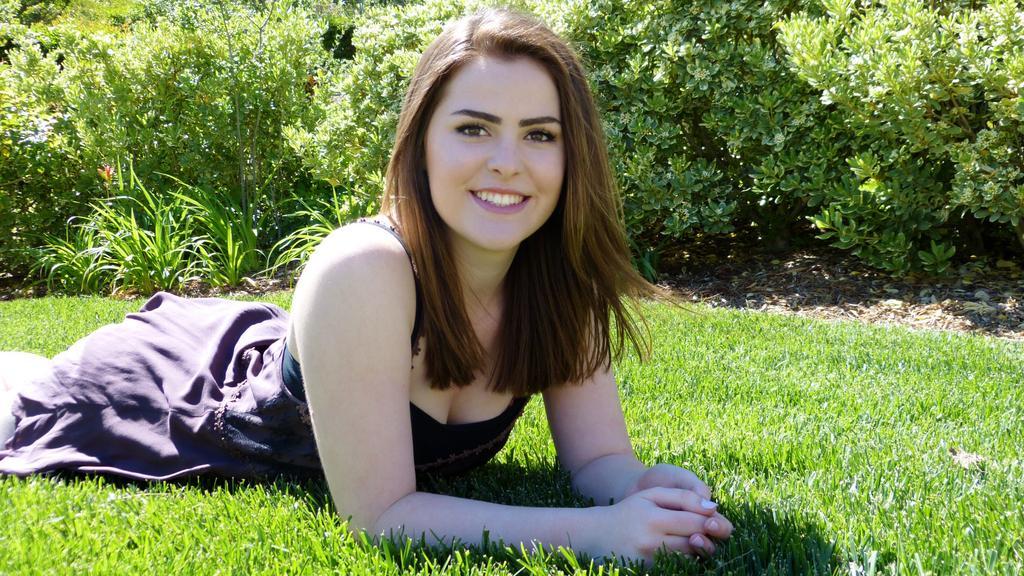Can you describe this image briefly? This image consists of a woman. She is lying on the grass. There are bushes at the top. 